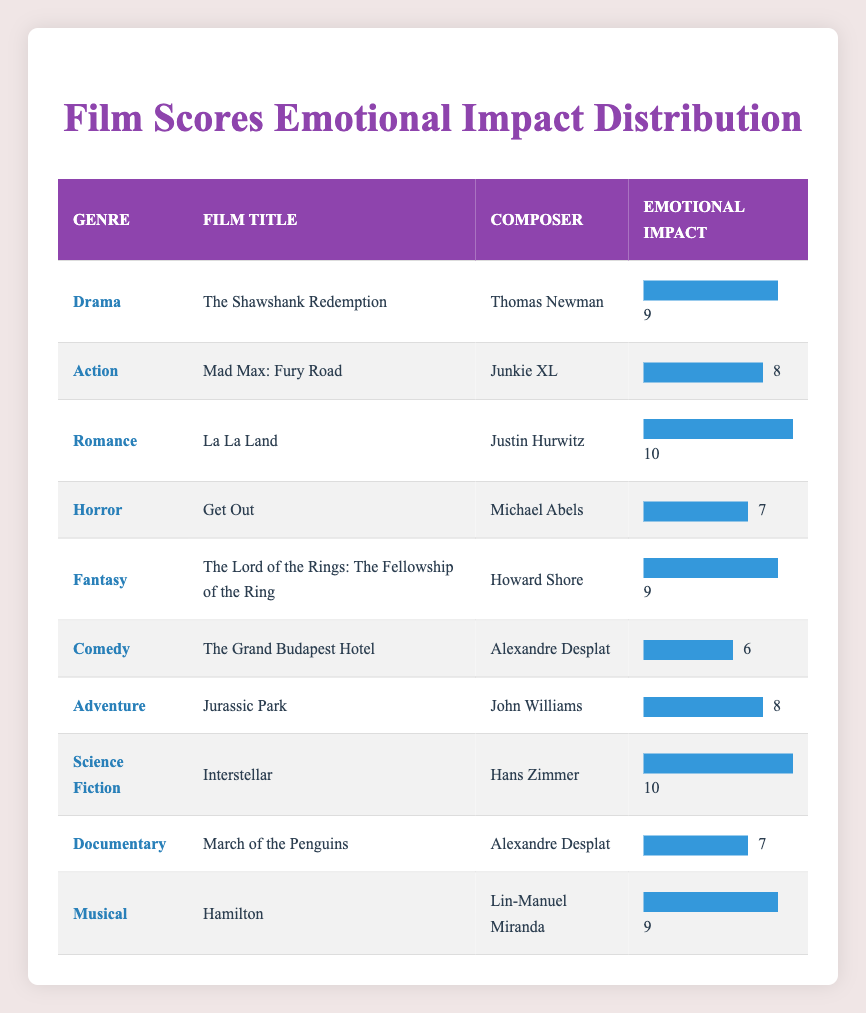What is the emotional impact rating of "La La Land"? The title "La La Land" is found in the Romance genre, and the emotional impact rating listed next to it is 10.
Answer: 10 Which film has the highest emotional impact rating? The highest emotional impact rating in the table is 10, which is credited to both "La La Land" and "Interstellar."
Answer: "La La Land" and "Interstellar" Is the emotional impact of "Jurassic Park" higher than that of "Get Out"? "Jurassic Park" has an emotional impact rating of 8, while "Get Out" has a rating of 7. Since 8 is greater than 7, the emotional impact of "Jurassic Park" is indeed higher.
Answer: Yes What is the average emotional impact rating of the films in the Fantasy and Science Fiction genres? The emotional impact ratings are 9 for "The Lord of the Rings: The Fellowship of the Ring" (Fantasy) and 10 for "Interstellar" (Science Fiction). The sum is 9 + 10 = 19, and there are 2 films. Therefore, the average is 19 / 2 = 9.5.
Answer: 9.5 How many genres have an emotional impact rating of 9? Three films have an emotional impact rating of 9: "The Shawshank Redemption" (Drama), "The Lord of the Rings: The Fellowship of the Ring" (Fantasy), and "Hamilton" (Musical). Counting the genres results in 3 distinct genres, which all have the same rating.
Answer: 3 Is there a Comedy film that has an emotional impact rating of 8 or higher? The film "The Grand Budapest Hotel" in the Comedy genre has an emotional impact rating of 6, which is below 8. Therefore, there is no Comedy film with a rating of 8 or higher.
Answer: No What genre does the composer Hans Zimmer belong to, and what is the emotional impact of his film? Hans Zimmer composed the film score for "Interstellar," which is categorized under Science Fiction, and it has an emotional impact rating of 10.
Answer: Science Fiction; 10 What is the difference in emotional impact ratings between the highest and lowest-rated films? The highest emotional impact rating is 10 (for "La La Land" and "Interstellar") and the lowest rating is 6 (for "The Grand Budapest Hotel"). The difference is 10 - 6 = 4.
Answer: 4 